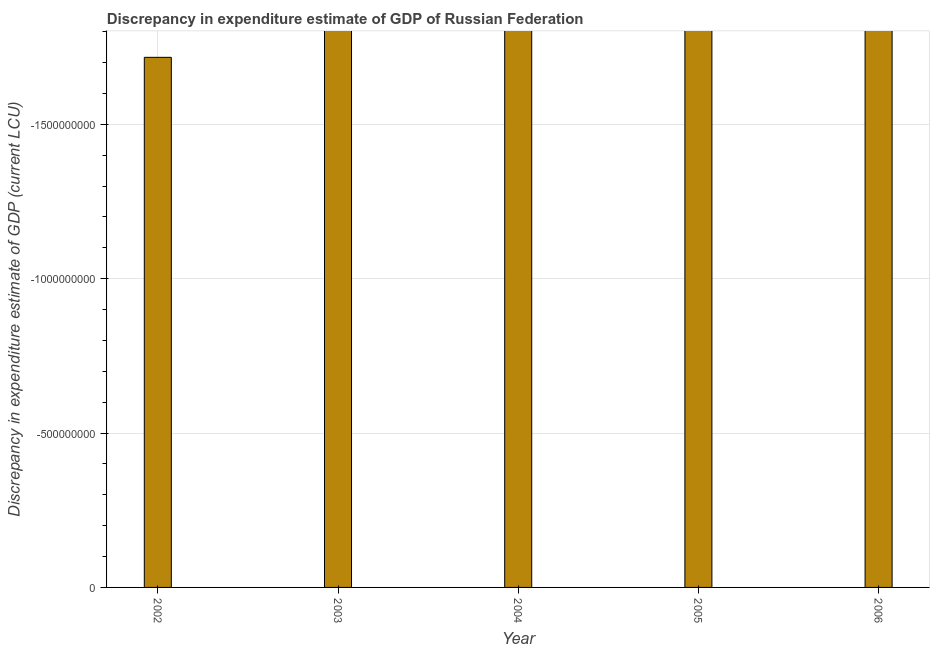What is the title of the graph?
Your answer should be compact. Discrepancy in expenditure estimate of GDP of Russian Federation. What is the label or title of the X-axis?
Offer a very short reply. Year. What is the label or title of the Y-axis?
Your answer should be very brief. Discrepancy in expenditure estimate of GDP (current LCU). What is the discrepancy in expenditure estimate of gdp in 2003?
Your response must be concise. 0. Across all years, what is the minimum discrepancy in expenditure estimate of gdp?
Provide a short and direct response. 0. What is the sum of the discrepancy in expenditure estimate of gdp?
Offer a terse response. 0. What is the average discrepancy in expenditure estimate of gdp per year?
Offer a very short reply. 0. In how many years, is the discrepancy in expenditure estimate of gdp greater than -200000000 LCU?
Keep it short and to the point. 0. How many years are there in the graph?
Ensure brevity in your answer.  5. What is the difference between two consecutive major ticks on the Y-axis?
Give a very brief answer. 5.00e+08. Are the values on the major ticks of Y-axis written in scientific E-notation?
Keep it short and to the point. No. 